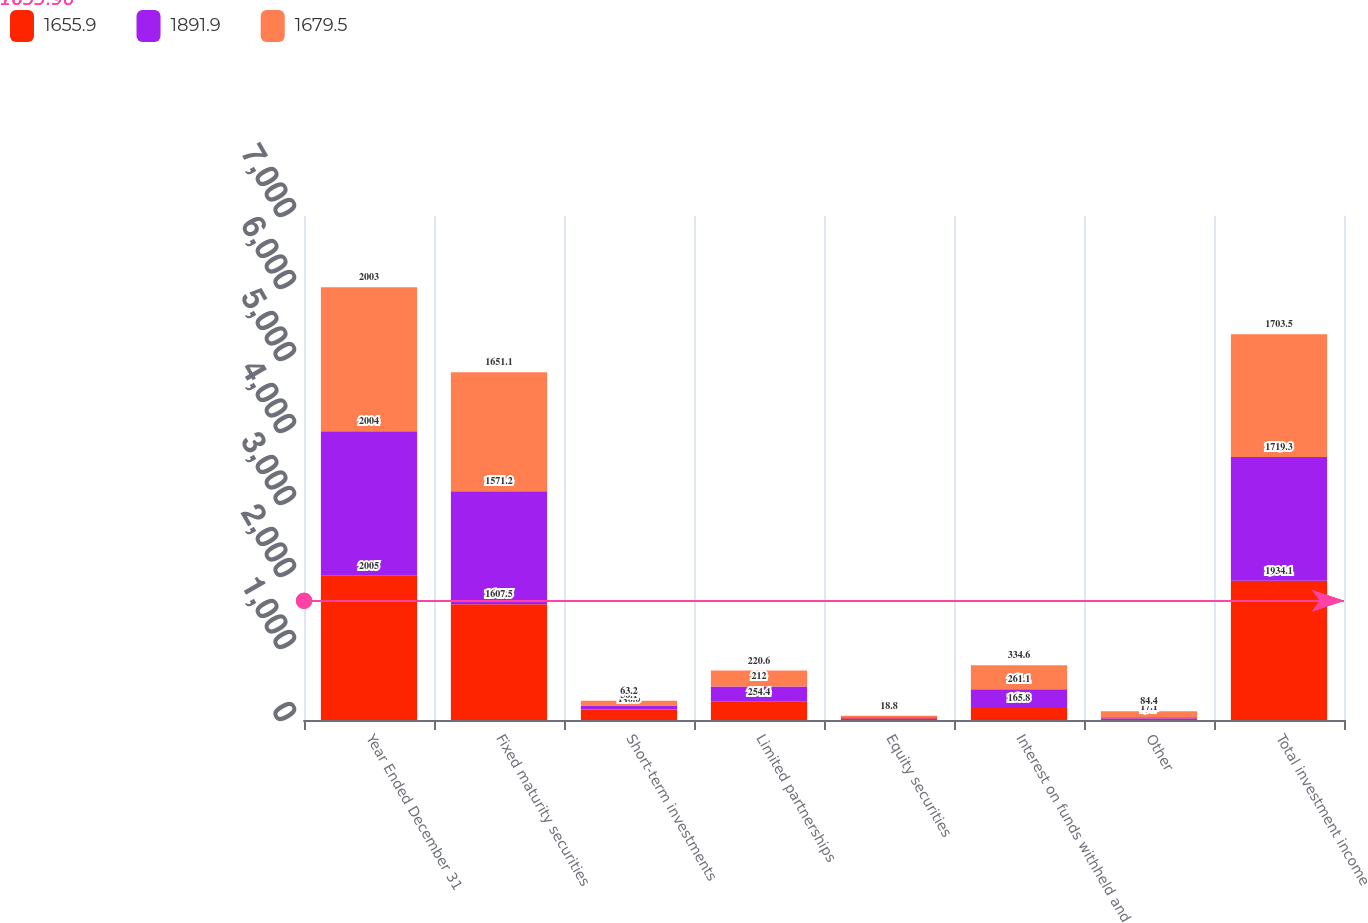Convert chart. <chart><loc_0><loc_0><loc_500><loc_500><stacked_bar_chart><ecel><fcel>Year Ended December 31<fcel>Fixed maturity securities<fcel>Short-term investments<fcel>Limited partnerships<fcel>Equity securities<fcel>Interest on funds withheld and<fcel>Other<fcel>Total investment income<nl><fcel>1655.9<fcel>2005<fcel>1607.5<fcel>146.6<fcel>254.4<fcel>25<fcel>165.8<fcel>19.7<fcel>1934.1<nl><fcel>1891.9<fcel>2004<fcel>1571.2<fcel>56.1<fcel>212<fcel>13.8<fcel>261.1<fcel>17.1<fcel>1719.3<nl><fcel>1679.5<fcel>2003<fcel>1651.1<fcel>63.2<fcel>220.6<fcel>18.8<fcel>334.6<fcel>84.4<fcel>1703.5<nl></chart> 